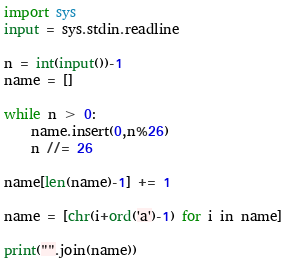Convert code to text. <code><loc_0><loc_0><loc_500><loc_500><_Python_>import sys
input = sys.stdin.readline

n = int(input())-1
name = []

while n > 0:
    name.insert(0,n%26)
    n //= 26

name[len(name)-1] += 1

name = [chr(i+ord('a')-1) for i in name]

print("".join(name))</code> 